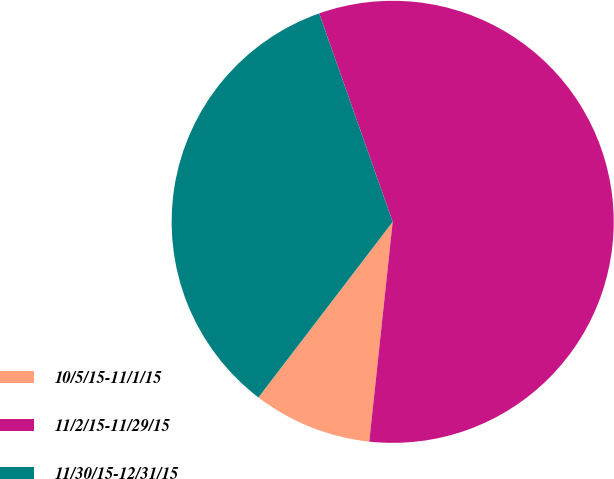<chart> <loc_0><loc_0><loc_500><loc_500><pie_chart><fcel>10/5/15-11/1/15<fcel>11/2/15-11/29/15<fcel>11/30/15-12/31/15<nl><fcel>8.7%<fcel>57.09%<fcel>34.22%<nl></chart> 